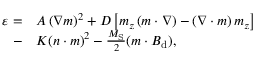<formula> <loc_0><loc_0><loc_500><loc_500>\begin{array} { r l } { \varepsilon = } & { A \left ( \nabla m \right ) ^ { 2 } + D \left [ m _ { z } \left ( m \cdot \nabla \right ) - \left ( \nabla \cdot m \right ) m _ { z } \right ] } \\ { - } & { K ( n \cdot m ) ^ { 2 } - \frac { M _ { S } } { 2 } ( m \cdot B _ { d } ) , } \end{array}</formula> 